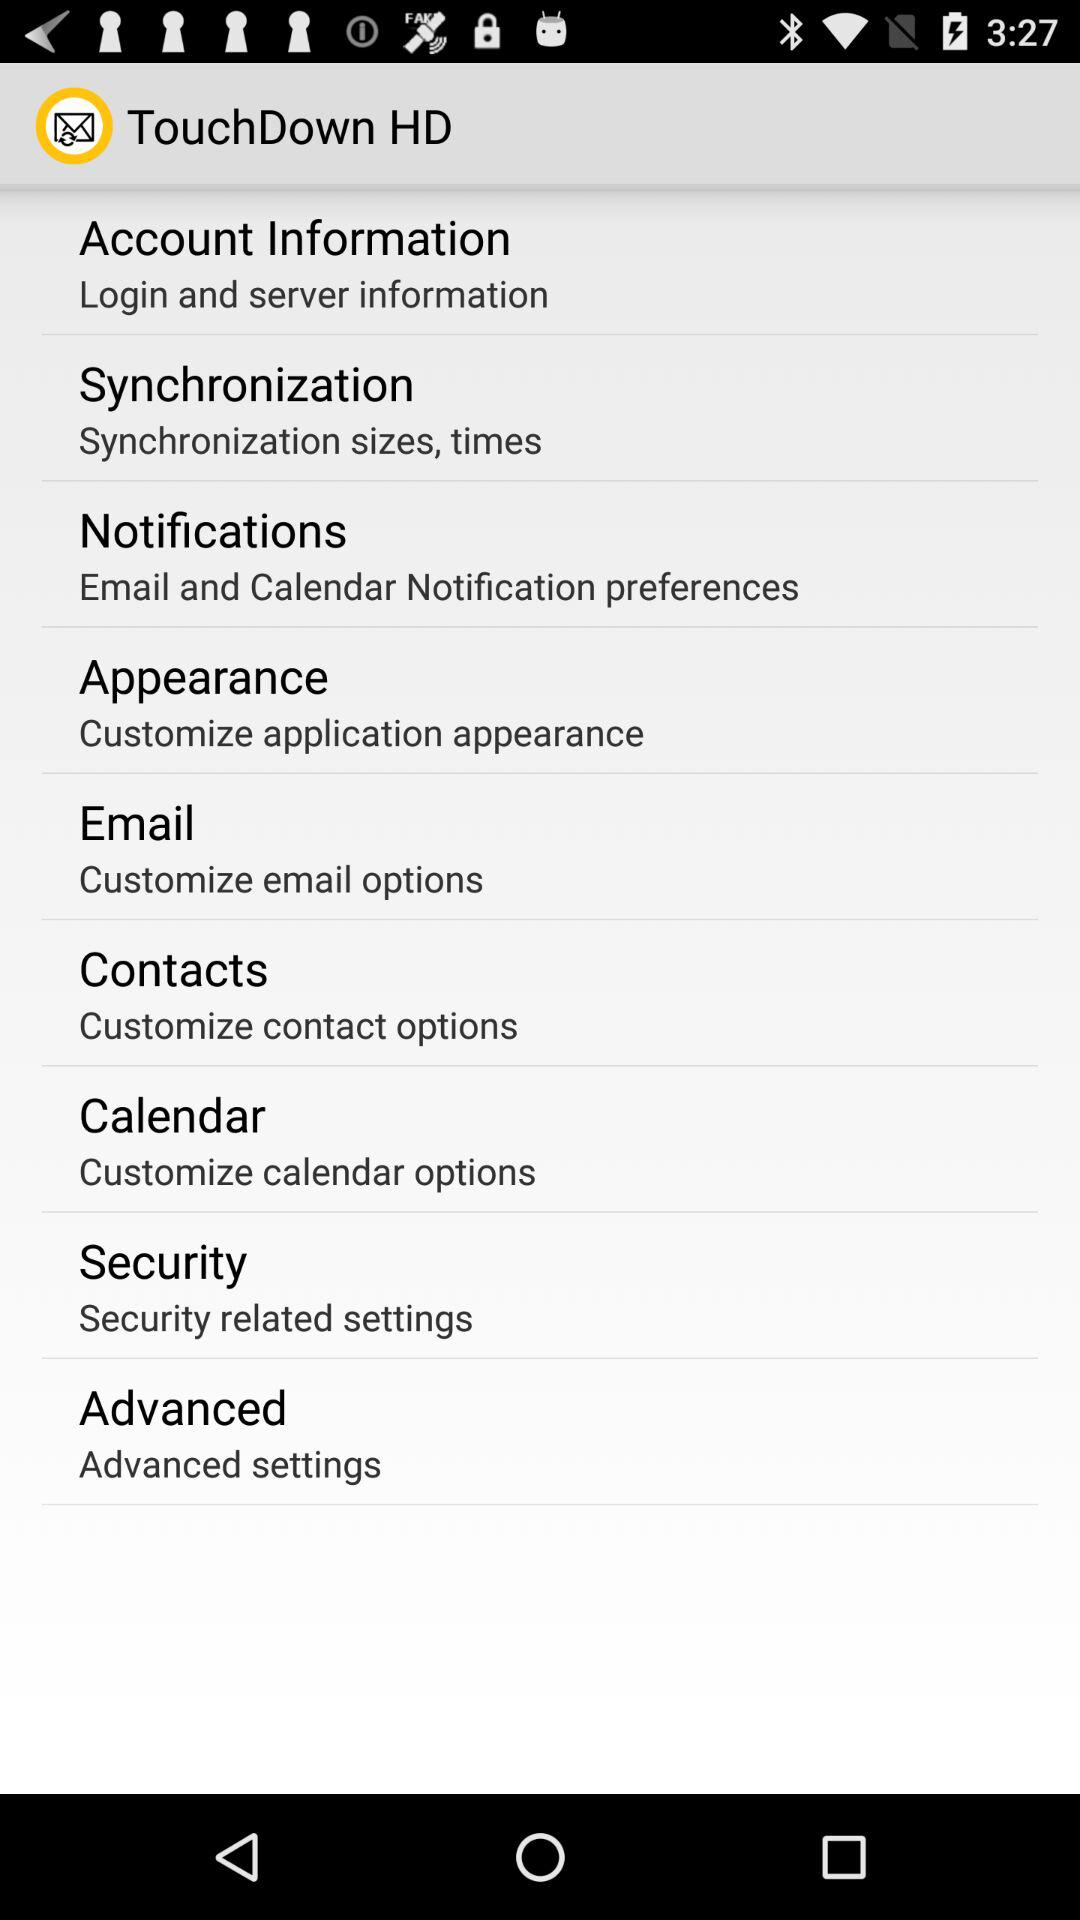What is the application name? The application name is "TouchDown HD". 